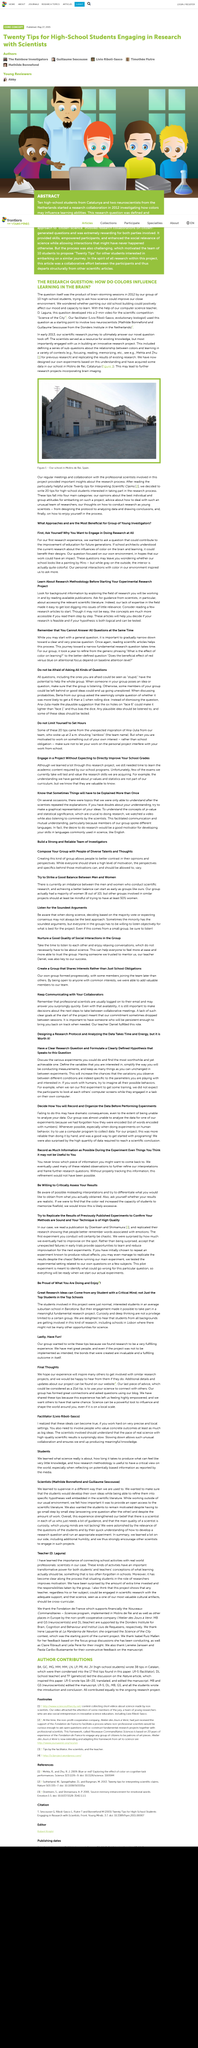Identify some key points in this picture. When working on a personal project of your own interest, it is important to ensure that it does not interfere with your work obligations from school. In 2012, a group of ten high-school students held a brain-storming session during which they posed the question, "How do colors influence learning in the brain? It is common for scientists to respond to emails in a timely manner. It is the case that concepts become more accessible when they are presented and understood in a step-by-step manner. Our team is named Rainbow. 